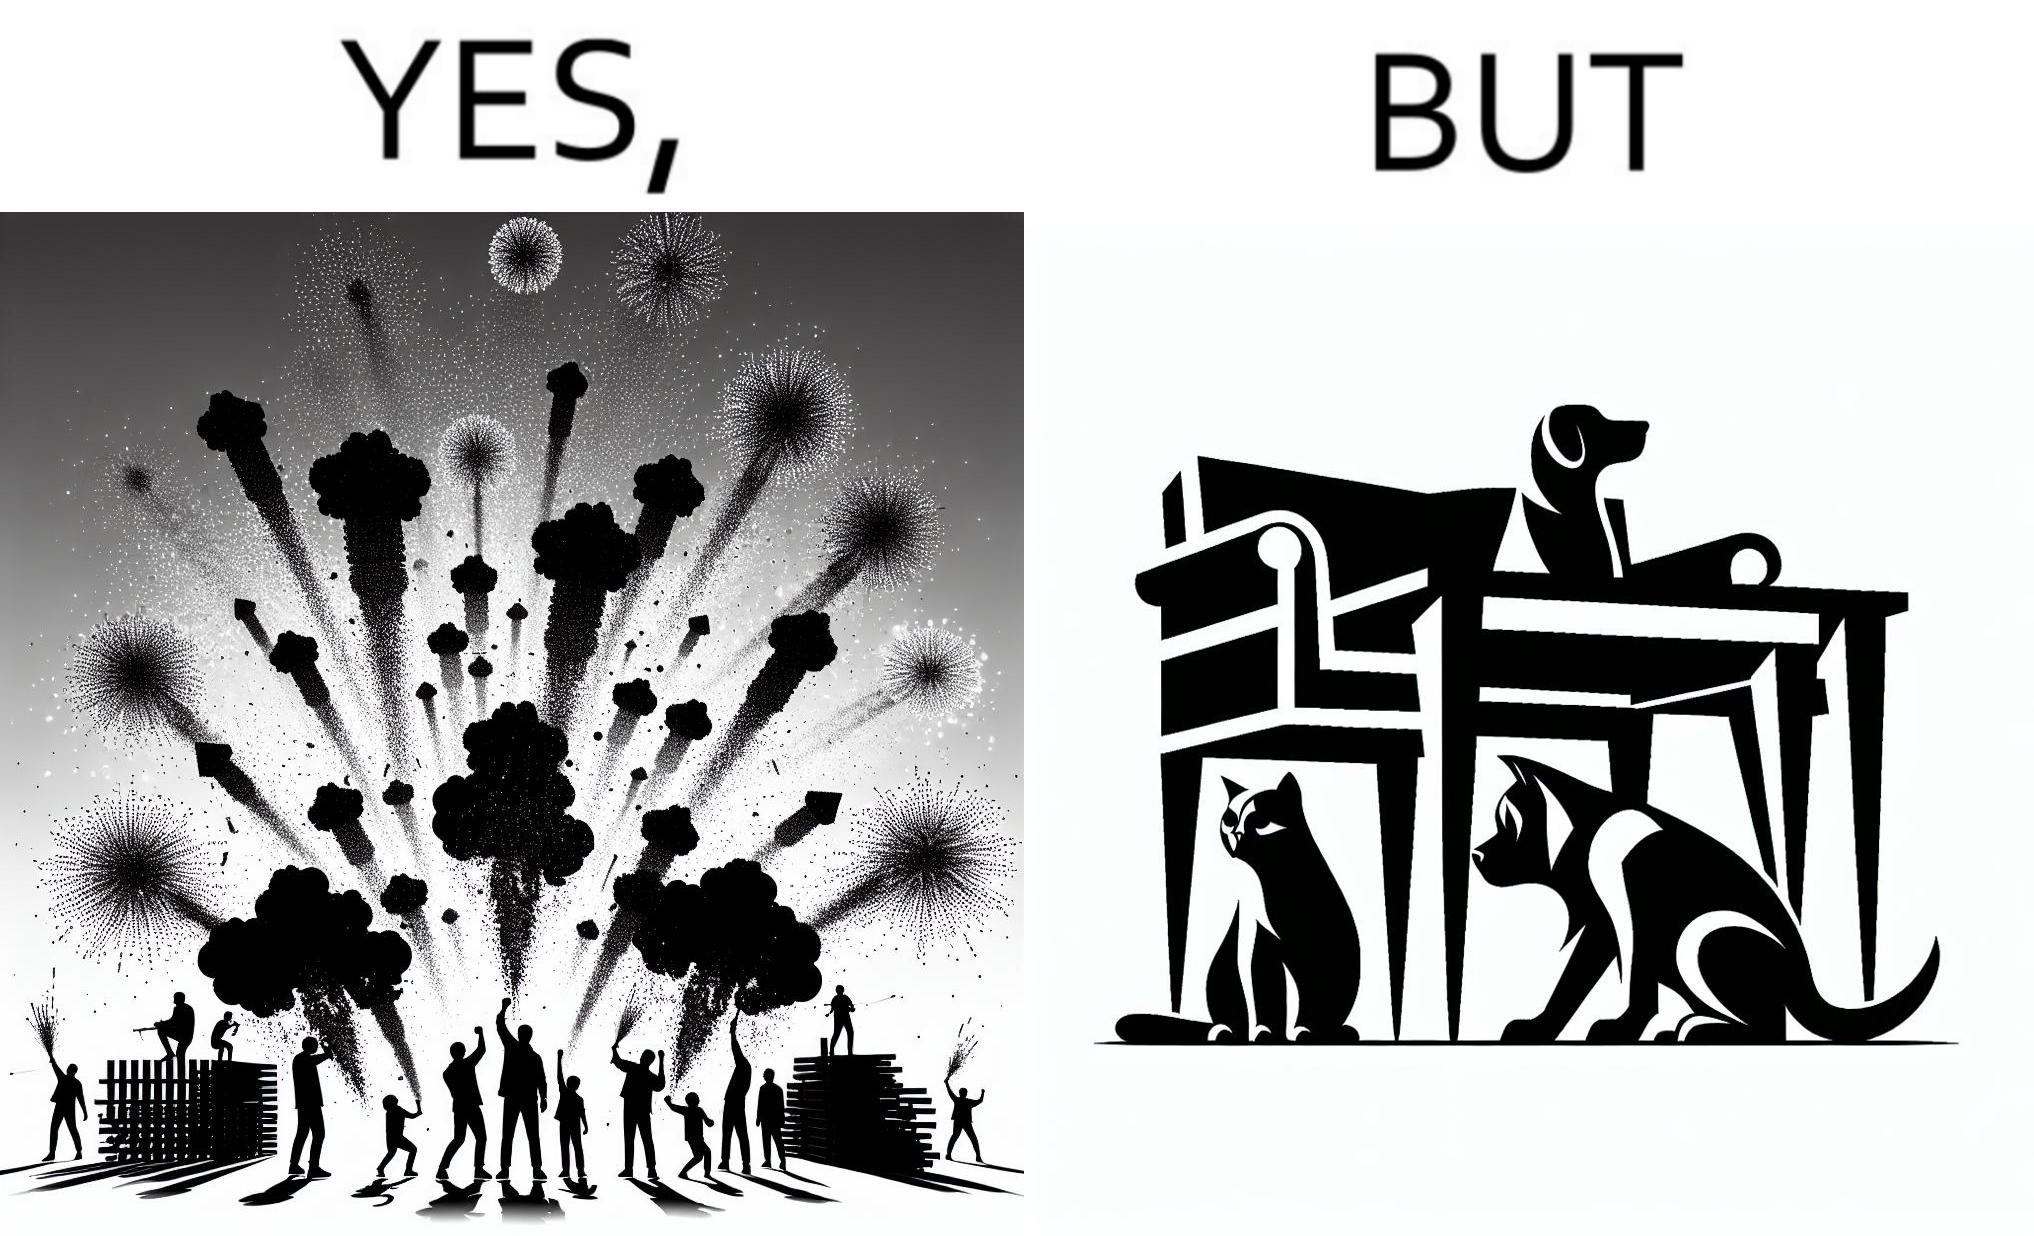What is shown in this image? The image is satirical because while firecrackers in the sky look pretty, not everyone likes them. Animals are very scared of the firecrackers. 